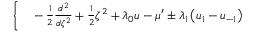Convert formula to latex. <formula><loc_0><loc_0><loc_500><loc_500>\begin{array} { r l } { \Big \{ } & - \frac { 1 } { 2 } \frac { d ^ { 2 } } { d \zeta ^ { 2 } } + \frac { 1 } { 2 } \zeta ^ { 2 } + \lambda _ { 0 } u - \mu ^ { \prime } \pm \lambda _ { 1 } \left ( u _ { 1 } - u _ { - 1 } \right ) } \end{array}</formula> 